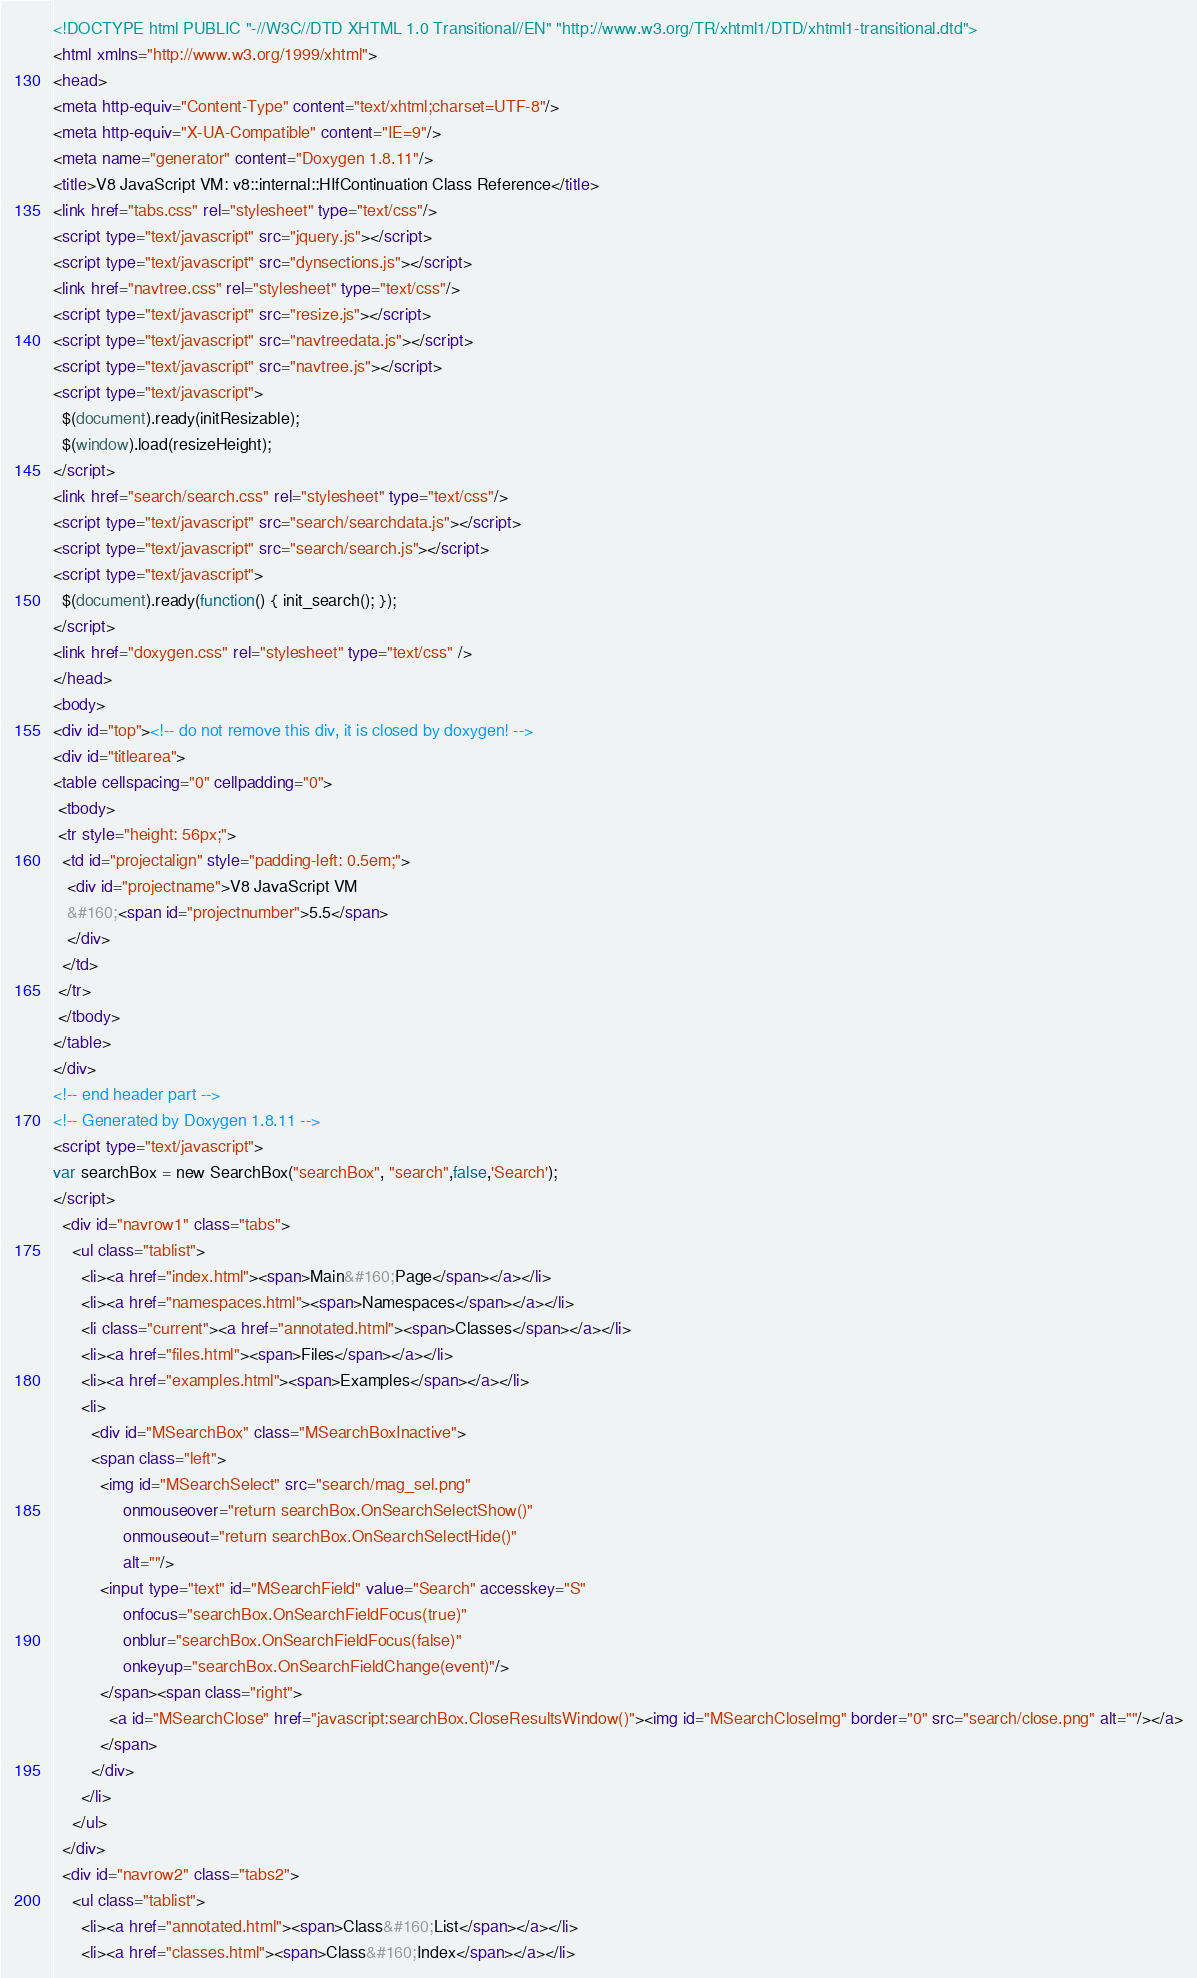Convert code to text. <code><loc_0><loc_0><loc_500><loc_500><_HTML_><!DOCTYPE html PUBLIC "-//W3C//DTD XHTML 1.0 Transitional//EN" "http://www.w3.org/TR/xhtml1/DTD/xhtml1-transitional.dtd">
<html xmlns="http://www.w3.org/1999/xhtml">
<head>
<meta http-equiv="Content-Type" content="text/xhtml;charset=UTF-8"/>
<meta http-equiv="X-UA-Compatible" content="IE=9"/>
<meta name="generator" content="Doxygen 1.8.11"/>
<title>V8 JavaScript VM: v8::internal::HIfContinuation Class Reference</title>
<link href="tabs.css" rel="stylesheet" type="text/css"/>
<script type="text/javascript" src="jquery.js"></script>
<script type="text/javascript" src="dynsections.js"></script>
<link href="navtree.css" rel="stylesheet" type="text/css"/>
<script type="text/javascript" src="resize.js"></script>
<script type="text/javascript" src="navtreedata.js"></script>
<script type="text/javascript" src="navtree.js"></script>
<script type="text/javascript">
  $(document).ready(initResizable);
  $(window).load(resizeHeight);
</script>
<link href="search/search.css" rel="stylesheet" type="text/css"/>
<script type="text/javascript" src="search/searchdata.js"></script>
<script type="text/javascript" src="search/search.js"></script>
<script type="text/javascript">
  $(document).ready(function() { init_search(); });
</script>
<link href="doxygen.css" rel="stylesheet" type="text/css" />
</head>
<body>
<div id="top"><!-- do not remove this div, it is closed by doxygen! -->
<div id="titlearea">
<table cellspacing="0" cellpadding="0">
 <tbody>
 <tr style="height: 56px;">
  <td id="projectalign" style="padding-left: 0.5em;">
   <div id="projectname">V8 JavaScript VM
   &#160;<span id="projectnumber">5.5</span>
   </div>
  </td>
 </tr>
 </tbody>
</table>
</div>
<!-- end header part -->
<!-- Generated by Doxygen 1.8.11 -->
<script type="text/javascript">
var searchBox = new SearchBox("searchBox", "search",false,'Search');
</script>
  <div id="navrow1" class="tabs">
    <ul class="tablist">
      <li><a href="index.html"><span>Main&#160;Page</span></a></li>
      <li><a href="namespaces.html"><span>Namespaces</span></a></li>
      <li class="current"><a href="annotated.html"><span>Classes</span></a></li>
      <li><a href="files.html"><span>Files</span></a></li>
      <li><a href="examples.html"><span>Examples</span></a></li>
      <li>
        <div id="MSearchBox" class="MSearchBoxInactive">
        <span class="left">
          <img id="MSearchSelect" src="search/mag_sel.png"
               onmouseover="return searchBox.OnSearchSelectShow()"
               onmouseout="return searchBox.OnSearchSelectHide()"
               alt=""/>
          <input type="text" id="MSearchField" value="Search" accesskey="S"
               onfocus="searchBox.OnSearchFieldFocus(true)" 
               onblur="searchBox.OnSearchFieldFocus(false)" 
               onkeyup="searchBox.OnSearchFieldChange(event)"/>
          </span><span class="right">
            <a id="MSearchClose" href="javascript:searchBox.CloseResultsWindow()"><img id="MSearchCloseImg" border="0" src="search/close.png" alt=""/></a>
          </span>
        </div>
      </li>
    </ul>
  </div>
  <div id="navrow2" class="tabs2">
    <ul class="tablist">
      <li><a href="annotated.html"><span>Class&#160;List</span></a></li>
      <li><a href="classes.html"><span>Class&#160;Index</span></a></li></code> 